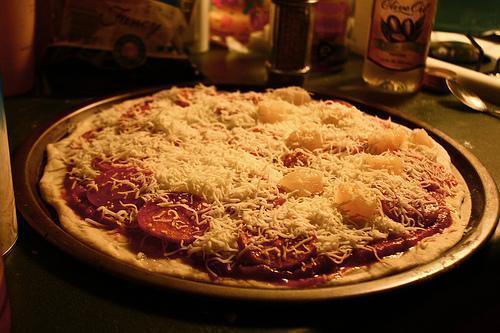How many pizzas are pictured?
Give a very brief answer. 1. 